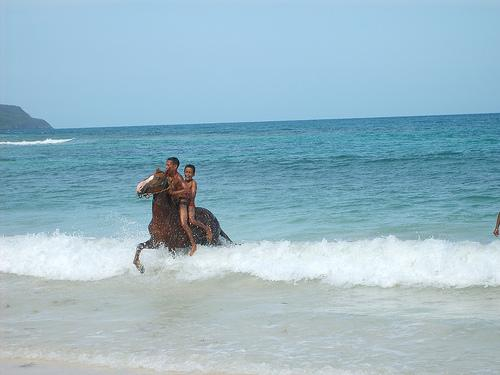Identify the main activity happening in the image. Two shirtless kids are riding a brown horse on the beach. Briefly describe the interaction between the boys and the horse. The two boys are riding the brown horse together, with one boy facing left and the other laughing. Mention any object or pattern that stands out on the horse's face. The horse has white fur on its brown face and a small white spot on its head. Comment on any noticeable movement of the horse. The horse is lifting up one of its front legs. Explain the state of the waves in the water. The waves are crashing on the shore with thick white sea foam. Provide a brief description of the weather and natural elements in the image. The image features a clear blue sky, a white foamy wave crashing on the beach, and a distant rocky mountain. Describe the scene in the far distance of the image. In the far distance, there is a mountain, a large brown cliff, and the horizon. Count the total number of people in the image and describe their appearances. There are two shirtless boys in the image, one is facing left and the other is laughing in a bathing suit. Locate the couple having a picnic on the right side of the image. They should be under a green and white striped umbrella, next to a red cooler. This instruction is misleading because there is no information provided about other people, let alone a couple having a picnic, in the image. The main focus of the image is on the beach landscape and the horse-riding event. Can you find the palm trees that line the edge of the beach? Look for tall trees with large, green leaves waving in the wind. No, it's not mentioned in the image. Can you find the flock of seagulls flying above the crashing waves? Look for several white birds in motion in the sky. This instruction is misleading because there is no mention of birds, specifically seagulls, in the image's provided information. The focus of the image is the beach, the horse, and the boys riding the horse, not any additional wildlife that might be present. Spot a group of people sunbathing on the stretch of sand, all wearing colorful swimsuits and sunglasses. This instruction is deceptive because there are no other groups or people mentioned in the image other than two boys riding the horse. The viewer might erroneously infer that the image features a crowded beach scene, but the information provided focuses only on the boys, the horse, and the landscape. 